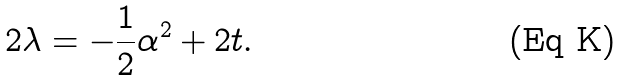<formula> <loc_0><loc_0><loc_500><loc_500>2 \lambda = - \frac { 1 } { 2 } \alpha ^ { 2 } + 2 t .</formula> 